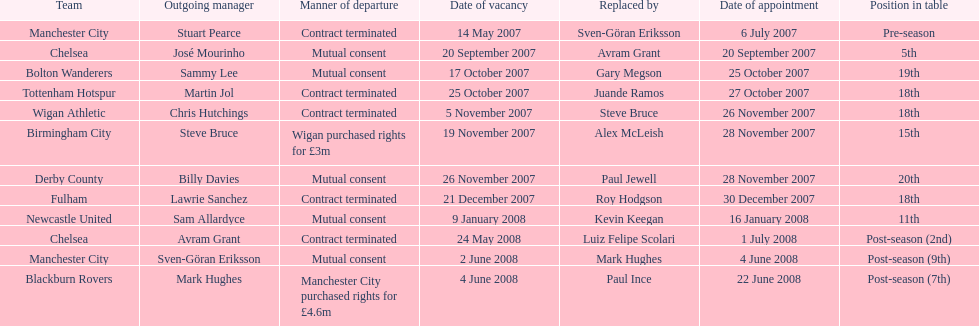Who was manager of manchester city after stuart pearce left in 2007? Sven-Göran Eriksson. 